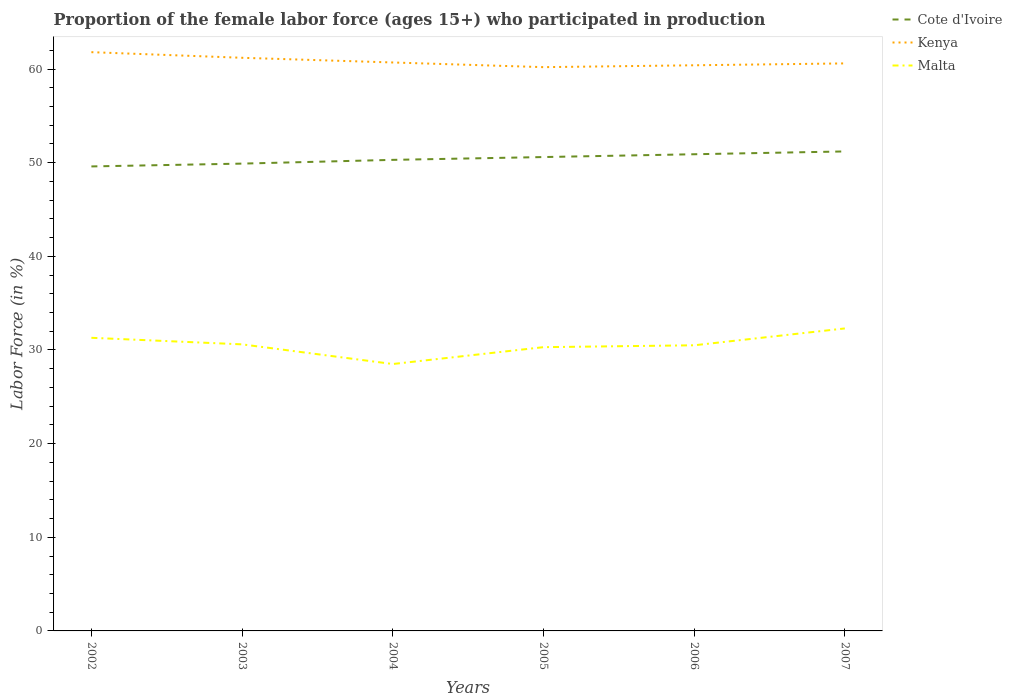How many different coloured lines are there?
Your response must be concise. 3. Is the number of lines equal to the number of legend labels?
Make the answer very short. Yes. Across all years, what is the maximum proportion of the female labor force who participated in production in Kenya?
Make the answer very short. 60.2. What is the total proportion of the female labor force who participated in production in Cote d'Ivoire in the graph?
Give a very brief answer. -1.6. What is the difference between the highest and the second highest proportion of the female labor force who participated in production in Malta?
Provide a succinct answer. 3.8. What is the difference between the highest and the lowest proportion of the female labor force who participated in production in Cote d'Ivoire?
Your response must be concise. 3. How many lines are there?
Keep it short and to the point. 3. What is the difference between two consecutive major ticks on the Y-axis?
Provide a succinct answer. 10. Where does the legend appear in the graph?
Make the answer very short. Top right. How are the legend labels stacked?
Your answer should be compact. Vertical. What is the title of the graph?
Provide a short and direct response. Proportion of the female labor force (ages 15+) who participated in production. What is the label or title of the X-axis?
Your answer should be very brief. Years. What is the Labor Force (in %) in Cote d'Ivoire in 2002?
Your answer should be compact. 49.6. What is the Labor Force (in %) in Kenya in 2002?
Your response must be concise. 61.8. What is the Labor Force (in %) in Malta in 2002?
Offer a terse response. 31.3. What is the Labor Force (in %) in Cote d'Ivoire in 2003?
Your response must be concise. 49.9. What is the Labor Force (in %) of Kenya in 2003?
Your response must be concise. 61.2. What is the Labor Force (in %) of Malta in 2003?
Your answer should be very brief. 30.6. What is the Labor Force (in %) in Cote d'Ivoire in 2004?
Make the answer very short. 50.3. What is the Labor Force (in %) in Kenya in 2004?
Provide a succinct answer. 60.7. What is the Labor Force (in %) in Malta in 2004?
Make the answer very short. 28.5. What is the Labor Force (in %) in Cote d'Ivoire in 2005?
Provide a short and direct response. 50.6. What is the Labor Force (in %) in Kenya in 2005?
Keep it short and to the point. 60.2. What is the Labor Force (in %) of Malta in 2005?
Offer a terse response. 30.3. What is the Labor Force (in %) in Cote d'Ivoire in 2006?
Provide a succinct answer. 50.9. What is the Labor Force (in %) of Kenya in 2006?
Offer a terse response. 60.4. What is the Labor Force (in %) of Malta in 2006?
Provide a succinct answer. 30.5. What is the Labor Force (in %) in Cote d'Ivoire in 2007?
Keep it short and to the point. 51.2. What is the Labor Force (in %) of Kenya in 2007?
Offer a very short reply. 60.6. What is the Labor Force (in %) of Malta in 2007?
Give a very brief answer. 32.3. Across all years, what is the maximum Labor Force (in %) in Cote d'Ivoire?
Offer a very short reply. 51.2. Across all years, what is the maximum Labor Force (in %) in Kenya?
Make the answer very short. 61.8. Across all years, what is the maximum Labor Force (in %) of Malta?
Your answer should be very brief. 32.3. Across all years, what is the minimum Labor Force (in %) in Cote d'Ivoire?
Ensure brevity in your answer.  49.6. Across all years, what is the minimum Labor Force (in %) in Kenya?
Make the answer very short. 60.2. What is the total Labor Force (in %) in Cote d'Ivoire in the graph?
Offer a terse response. 302.5. What is the total Labor Force (in %) in Kenya in the graph?
Offer a terse response. 364.9. What is the total Labor Force (in %) in Malta in the graph?
Your answer should be very brief. 183.5. What is the difference between the Labor Force (in %) of Cote d'Ivoire in 2002 and that in 2003?
Your response must be concise. -0.3. What is the difference between the Labor Force (in %) in Malta in 2002 and that in 2003?
Make the answer very short. 0.7. What is the difference between the Labor Force (in %) of Cote d'Ivoire in 2002 and that in 2005?
Provide a short and direct response. -1. What is the difference between the Labor Force (in %) in Cote d'Ivoire in 2002 and that in 2006?
Offer a very short reply. -1.3. What is the difference between the Labor Force (in %) in Kenya in 2002 and that in 2006?
Provide a succinct answer. 1.4. What is the difference between the Labor Force (in %) of Malta in 2002 and that in 2006?
Your answer should be compact. 0.8. What is the difference between the Labor Force (in %) in Cote d'Ivoire in 2002 and that in 2007?
Your answer should be very brief. -1.6. What is the difference between the Labor Force (in %) in Malta in 2002 and that in 2007?
Provide a succinct answer. -1. What is the difference between the Labor Force (in %) in Cote d'Ivoire in 2003 and that in 2004?
Ensure brevity in your answer.  -0.4. What is the difference between the Labor Force (in %) in Kenya in 2003 and that in 2004?
Your response must be concise. 0.5. What is the difference between the Labor Force (in %) of Malta in 2003 and that in 2004?
Provide a succinct answer. 2.1. What is the difference between the Labor Force (in %) in Kenya in 2003 and that in 2005?
Offer a terse response. 1. What is the difference between the Labor Force (in %) in Malta in 2003 and that in 2005?
Provide a succinct answer. 0.3. What is the difference between the Labor Force (in %) in Cote d'Ivoire in 2003 and that in 2007?
Your answer should be very brief. -1.3. What is the difference between the Labor Force (in %) in Malta in 2003 and that in 2007?
Make the answer very short. -1.7. What is the difference between the Labor Force (in %) of Kenya in 2004 and that in 2006?
Your answer should be compact. 0.3. What is the difference between the Labor Force (in %) of Malta in 2004 and that in 2006?
Make the answer very short. -2. What is the difference between the Labor Force (in %) of Cote d'Ivoire in 2004 and that in 2007?
Provide a succinct answer. -0.9. What is the difference between the Labor Force (in %) in Cote d'Ivoire in 2005 and that in 2006?
Give a very brief answer. -0.3. What is the difference between the Labor Force (in %) of Kenya in 2005 and that in 2006?
Give a very brief answer. -0.2. What is the difference between the Labor Force (in %) in Kenya in 2005 and that in 2007?
Offer a very short reply. -0.4. What is the difference between the Labor Force (in %) of Malta in 2005 and that in 2007?
Offer a very short reply. -2. What is the difference between the Labor Force (in %) of Kenya in 2006 and that in 2007?
Your response must be concise. -0.2. What is the difference between the Labor Force (in %) in Cote d'Ivoire in 2002 and the Labor Force (in %) in Kenya in 2003?
Your answer should be very brief. -11.6. What is the difference between the Labor Force (in %) in Cote d'Ivoire in 2002 and the Labor Force (in %) in Malta in 2003?
Your answer should be compact. 19. What is the difference between the Labor Force (in %) of Kenya in 2002 and the Labor Force (in %) of Malta in 2003?
Keep it short and to the point. 31.2. What is the difference between the Labor Force (in %) of Cote d'Ivoire in 2002 and the Labor Force (in %) of Kenya in 2004?
Ensure brevity in your answer.  -11.1. What is the difference between the Labor Force (in %) of Cote d'Ivoire in 2002 and the Labor Force (in %) of Malta in 2004?
Your answer should be compact. 21.1. What is the difference between the Labor Force (in %) in Kenya in 2002 and the Labor Force (in %) in Malta in 2004?
Provide a short and direct response. 33.3. What is the difference between the Labor Force (in %) in Cote d'Ivoire in 2002 and the Labor Force (in %) in Malta in 2005?
Your answer should be very brief. 19.3. What is the difference between the Labor Force (in %) in Kenya in 2002 and the Labor Force (in %) in Malta in 2005?
Your answer should be very brief. 31.5. What is the difference between the Labor Force (in %) in Kenya in 2002 and the Labor Force (in %) in Malta in 2006?
Your answer should be very brief. 31.3. What is the difference between the Labor Force (in %) of Cote d'Ivoire in 2002 and the Labor Force (in %) of Kenya in 2007?
Keep it short and to the point. -11. What is the difference between the Labor Force (in %) in Cote d'Ivoire in 2002 and the Labor Force (in %) in Malta in 2007?
Your response must be concise. 17.3. What is the difference between the Labor Force (in %) of Kenya in 2002 and the Labor Force (in %) of Malta in 2007?
Offer a terse response. 29.5. What is the difference between the Labor Force (in %) in Cote d'Ivoire in 2003 and the Labor Force (in %) in Kenya in 2004?
Provide a succinct answer. -10.8. What is the difference between the Labor Force (in %) in Cote d'Ivoire in 2003 and the Labor Force (in %) in Malta in 2004?
Give a very brief answer. 21.4. What is the difference between the Labor Force (in %) in Kenya in 2003 and the Labor Force (in %) in Malta in 2004?
Keep it short and to the point. 32.7. What is the difference between the Labor Force (in %) in Cote d'Ivoire in 2003 and the Labor Force (in %) in Kenya in 2005?
Provide a succinct answer. -10.3. What is the difference between the Labor Force (in %) of Cote d'Ivoire in 2003 and the Labor Force (in %) of Malta in 2005?
Keep it short and to the point. 19.6. What is the difference between the Labor Force (in %) in Kenya in 2003 and the Labor Force (in %) in Malta in 2005?
Your response must be concise. 30.9. What is the difference between the Labor Force (in %) in Cote d'Ivoire in 2003 and the Labor Force (in %) in Malta in 2006?
Your answer should be very brief. 19.4. What is the difference between the Labor Force (in %) of Kenya in 2003 and the Labor Force (in %) of Malta in 2006?
Offer a very short reply. 30.7. What is the difference between the Labor Force (in %) of Cote d'Ivoire in 2003 and the Labor Force (in %) of Kenya in 2007?
Offer a terse response. -10.7. What is the difference between the Labor Force (in %) in Cote d'Ivoire in 2003 and the Labor Force (in %) in Malta in 2007?
Ensure brevity in your answer.  17.6. What is the difference between the Labor Force (in %) of Kenya in 2003 and the Labor Force (in %) of Malta in 2007?
Offer a terse response. 28.9. What is the difference between the Labor Force (in %) of Kenya in 2004 and the Labor Force (in %) of Malta in 2005?
Your response must be concise. 30.4. What is the difference between the Labor Force (in %) in Cote d'Ivoire in 2004 and the Labor Force (in %) in Kenya in 2006?
Provide a succinct answer. -10.1. What is the difference between the Labor Force (in %) in Cote d'Ivoire in 2004 and the Labor Force (in %) in Malta in 2006?
Your answer should be compact. 19.8. What is the difference between the Labor Force (in %) of Kenya in 2004 and the Labor Force (in %) of Malta in 2006?
Offer a very short reply. 30.2. What is the difference between the Labor Force (in %) in Kenya in 2004 and the Labor Force (in %) in Malta in 2007?
Your answer should be compact. 28.4. What is the difference between the Labor Force (in %) in Cote d'Ivoire in 2005 and the Labor Force (in %) in Malta in 2006?
Ensure brevity in your answer.  20.1. What is the difference between the Labor Force (in %) in Kenya in 2005 and the Labor Force (in %) in Malta in 2006?
Provide a short and direct response. 29.7. What is the difference between the Labor Force (in %) of Cote d'Ivoire in 2005 and the Labor Force (in %) of Kenya in 2007?
Your response must be concise. -10. What is the difference between the Labor Force (in %) in Cote d'Ivoire in 2005 and the Labor Force (in %) in Malta in 2007?
Provide a short and direct response. 18.3. What is the difference between the Labor Force (in %) in Kenya in 2005 and the Labor Force (in %) in Malta in 2007?
Provide a short and direct response. 27.9. What is the difference between the Labor Force (in %) of Cote d'Ivoire in 2006 and the Labor Force (in %) of Malta in 2007?
Make the answer very short. 18.6. What is the difference between the Labor Force (in %) of Kenya in 2006 and the Labor Force (in %) of Malta in 2007?
Make the answer very short. 28.1. What is the average Labor Force (in %) in Cote d'Ivoire per year?
Your answer should be compact. 50.42. What is the average Labor Force (in %) in Kenya per year?
Offer a terse response. 60.82. What is the average Labor Force (in %) of Malta per year?
Your response must be concise. 30.58. In the year 2002, what is the difference between the Labor Force (in %) of Cote d'Ivoire and Labor Force (in %) of Kenya?
Offer a very short reply. -12.2. In the year 2002, what is the difference between the Labor Force (in %) in Kenya and Labor Force (in %) in Malta?
Offer a terse response. 30.5. In the year 2003, what is the difference between the Labor Force (in %) of Cote d'Ivoire and Labor Force (in %) of Kenya?
Ensure brevity in your answer.  -11.3. In the year 2003, what is the difference between the Labor Force (in %) in Cote d'Ivoire and Labor Force (in %) in Malta?
Your answer should be very brief. 19.3. In the year 2003, what is the difference between the Labor Force (in %) in Kenya and Labor Force (in %) in Malta?
Your response must be concise. 30.6. In the year 2004, what is the difference between the Labor Force (in %) of Cote d'Ivoire and Labor Force (in %) of Malta?
Your response must be concise. 21.8. In the year 2004, what is the difference between the Labor Force (in %) in Kenya and Labor Force (in %) in Malta?
Offer a terse response. 32.2. In the year 2005, what is the difference between the Labor Force (in %) of Cote d'Ivoire and Labor Force (in %) of Kenya?
Offer a very short reply. -9.6. In the year 2005, what is the difference between the Labor Force (in %) of Cote d'Ivoire and Labor Force (in %) of Malta?
Your response must be concise. 20.3. In the year 2005, what is the difference between the Labor Force (in %) of Kenya and Labor Force (in %) of Malta?
Keep it short and to the point. 29.9. In the year 2006, what is the difference between the Labor Force (in %) in Cote d'Ivoire and Labor Force (in %) in Malta?
Offer a terse response. 20.4. In the year 2006, what is the difference between the Labor Force (in %) in Kenya and Labor Force (in %) in Malta?
Ensure brevity in your answer.  29.9. In the year 2007, what is the difference between the Labor Force (in %) of Cote d'Ivoire and Labor Force (in %) of Kenya?
Offer a very short reply. -9.4. In the year 2007, what is the difference between the Labor Force (in %) in Kenya and Labor Force (in %) in Malta?
Keep it short and to the point. 28.3. What is the ratio of the Labor Force (in %) of Cote d'Ivoire in 2002 to that in 2003?
Your response must be concise. 0.99. What is the ratio of the Labor Force (in %) of Kenya in 2002 to that in 2003?
Offer a terse response. 1.01. What is the ratio of the Labor Force (in %) in Malta in 2002 to that in 2003?
Provide a succinct answer. 1.02. What is the ratio of the Labor Force (in %) of Cote d'Ivoire in 2002 to that in 2004?
Provide a succinct answer. 0.99. What is the ratio of the Labor Force (in %) in Kenya in 2002 to that in 2004?
Your response must be concise. 1.02. What is the ratio of the Labor Force (in %) of Malta in 2002 to that in 2004?
Provide a succinct answer. 1.1. What is the ratio of the Labor Force (in %) of Cote d'Ivoire in 2002 to that in 2005?
Give a very brief answer. 0.98. What is the ratio of the Labor Force (in %) of Kenya in 2002 to that in 2005?
Your answer should be very brief. 1.03. What is the ratio of the Labor Force (in %) of Malta in 2002 to that in 2005?
Make the answer very short. 1.03. What is the ratio of the Labor Force (in %) in Cote d'Ivoire in 2002 to that in 2006?
Ensure brevity in your answer.  0.97. What is the ratio of the Labor Force (in %) of Kenya in 2002 to that in 2006?
Ensure brevity in your answer.  1.02. What is the ratio of the Labor Force (in %) in Malta in 2002 to that in 2006?
Your response must be concise. 1.03. What is the ratio of the Labor Force (in %) in Cote d'Ivoire in 2002 to that in 2007?
Your answer should be very brief. 0.97. What is the ratio of the Labor Force (in %) in Kenya in 2002 to that in 2007?
Make the answer very short. 1.02. What is the ratio of the Labor Force (in %) of Malta in 2002 to that in 2007?
Offer a terse response. 0.97. What is the ratio of the Labor Force (in %) in Cote d'Ivoire in 2003 to that in 2004?
Your response must be concise. 0.99. What is the ratio of the Labor Force (in %) of Kenya in 2003 to that in 2004?
Provide a succinct answer. 1.01. What is the ratio of the Labor Force (in %) of Malta in 2003 to that in 2004?
Provide a short and direct response. 1.07. What is the ratio of the Labor Force (in %) in Cote d'Ivoire in 2003 to that in 2005?
Offer a terse response. 0.99. What is the ratio of the Labor Force (in %) of Kenya in 2003 to that in 2005?
Your answer should be very brief. 1.02. What is the ratio of the Labor Force (in %) of Malta in 2003 to that in 2005?
Your answer should be very brief. 1.01. What is the ratio of the Labor Force (in %) of Cote d'Ivoire in 2003 to that in 2006?
Your response must be concise. 0.98. What is the ratio of the Labor Force (in %) of Kenya in 2003 to that in 2006?
Offer a terse response. 1.01. What is the ratio of the Labor Force (in %) in Malta in 2003 to that in 2006?
Your answer should be compact. 1. What is the ratio of the Labor Force (in %) of Cote d'Ivoire in 2003 to that in 2007?
Your answer should be very brief. 0.97. What is the ratio of the Labor Force (in %) in Kenya in 2003 to that in 2007?
Offer a terse response. 1.01. What is the ratio of the Labor Force (in %) in Malta in 2003 to that in 2007?
Your answer should be very brief. 0.95. What is the ratio of the Labor Force (in %) of Cote d'Ivoire in 2004 to that in 2005?
Make the answer very short. 0.99. What is the ratio of the Labor Force (in %) of Kenya in 2004 to that in 2005?
Give a very brief answer. 1.01. What is the ratio of the Labor Force (in %) in Malta in 2004 to that in 2005?
Ensure brevity in your answer.  0.94. What is the ratio of the Labor Force (in %) of Cote d'Ivoire in 2004 to that in 2006?
Your answer should be very brief. 0.99. What is the ratio of the Labor Force (in %) of Kenya in 2004 to that in 2006?
Ensure brevity in your answer.  1. What is the ratio of the Labor Force (in %) in Malta in 2004 to that in 2006?
Give a very brief answer. 0.93. What is the ratio of the Labor Force (in %) in Cote d'Ivoire in 2004 to that in 2007?
Make the answer very short. 0.98. What is the ratio of the Labor Force (in %) in Malta in 2004 to that in 2007?
Your response must be concise. 0.88. What is the ratio of the Labor Force (in %) in Cote d'Ivoire in 2005 to that in 2006?
Keep it short and to the point. 0.99. What is the ratio of the Labor Force (in %) of Cote d'Ivoire in 2005 to that in 2007?
Keep it short and to the point. 0.99. What is the ratio of the Labor Force (in %) of Kenya in 2005 to that in 2007?
Give a very brief answer. 0.99. What is the ratio of the Labor Force (in %) in Malta in 2005 to that in 2007?
Make the answer very short. 0.94. What is the ratio of the Labor Force (in %) of Cote d'Ivoire in 2006 to that in 2007?
Give a very brief answer. 0.99. What is the ratio of the Labor Force (in %) of Kenya in 2006 to that in 2007?
Ensure brevity in your answer.  1. What is the ratio of the Labor Force (in %) of Malta in 2006 to that in 2007?
Your answer should be compact. 0.94. What is the difference between the highest and the second highest Labor Force (in %) in Cote d'Ivoire?
Your response must be concise. 0.3. What is the difference between the highest and the second highest Labor Force (in %) of Kenya?
Provide a succinct answer. 0.6. What is the difference between the highest and the lowest Labor Force (in %) of Kenya?
Provide a succinct answer. 1.6. What is the difference between the highest and the lowest Labor Force (in %) of Malta?
Keep it short and to the point. 3.8. 